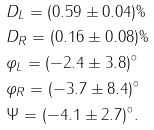Convert formula to latex. <formula><loc_0><loc_0><loc_500><loc_500>& D _ { L } = ( 0 . 5 9 \pm 0 . 0 4 ) \% \\ & D _ { R } = ( 0 . 1 6 \pm 0 . 0 8 ) \% \\ & \varphi _ { L } = ( - 2 . 4 \pm 3 . 8 ) ^ { \circ } \\ & \varphi _ { R } = ( - 3 . 7 \pm 8 . 4 ) ^ { \circ } \\ & \Psi = ( - 4 . 1 \pm 2 . 7 ) ^ { \circ } .</formula> 